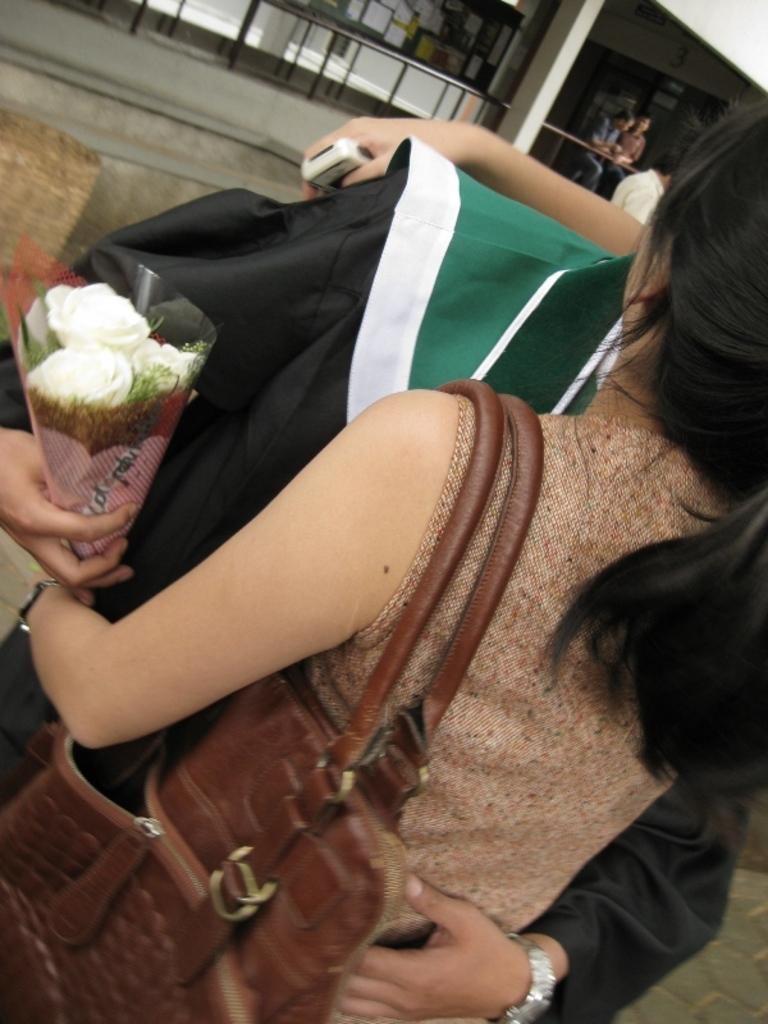How would you summarize this image in a sentence or two? In this image we can see a woman wearing the bag. We can also see a person holding the bouquet. In the background we can see the building with a pillar, railing, people and also a board with the papers attached to it. 